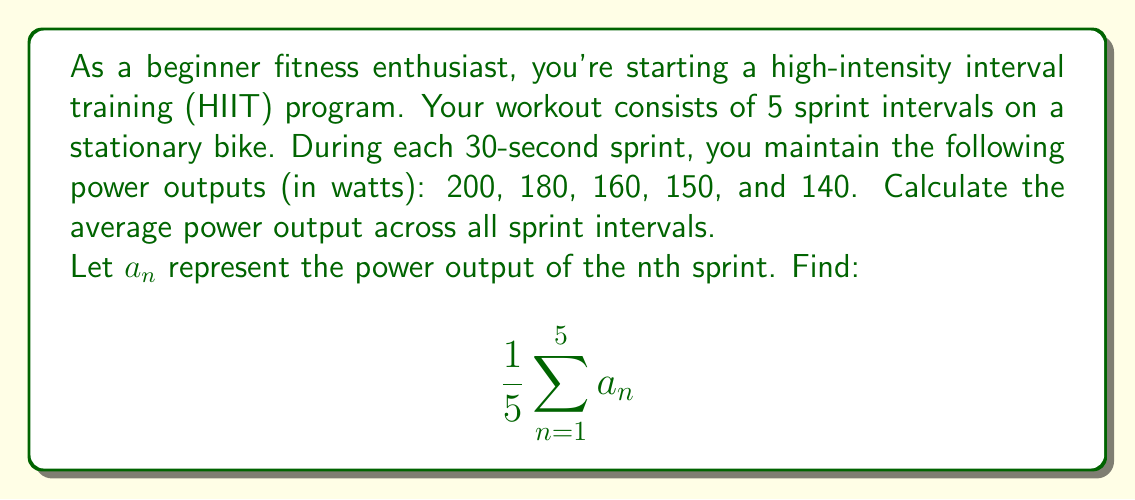Can you solve this math problem? To solve this problem, we'll follow these steps:

1) First, let's identify the values of $a_n$ for each sprint:
   $a_1 = 200$ watts
   $a_2 = 180$ watts
   $a_3 = 160$ watts
   $a_4 = 150$ watts
   $a_5 = 140$ watts

2) The formula given is the arithmetic mean of these 5 values:

   $$\frac{1}{5}\sum_{n=1}^{5} a_n$$

   This can be expanded as:

   $$\frac{1}{5}(a_1 + a_2 + a_3 + a_4 + a_5)$$

3) Now, let's substitute the values:

   $$\frac{1}{5}(200 + 180 + 160 + 150 + 140)$$

4) Add the values inside the parentheses:

   $$\frac{1}{5}(830)$$

5) Perform the division:

   $$166$$

Therefore, the average power output across all sprint intervals is 166 watts.
Answer: $166$ watts 